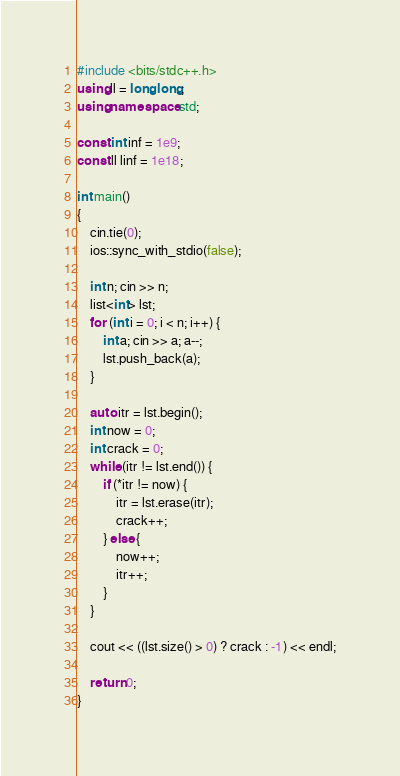<code> <loc_0><loc_0><loc_500><loc_500><_C++_>#include <bits/stdc++.h>
using ll = long long;
using namespace std;

const int inf = 1e9;
const ll linf = 1e18;

int main()
{
    cin.tie(0);
    ios::sync_with_stdio(false);

    int n; cin >> n;
    list<int> lst;
    for (int i = 0; i < n; i++) {
        int a; cin >> a; a--;
        lst.push_back(a);
    }

    auto itr = lst.begin();
    int now = 0;
    int crack = 0;
    while (itr != lst.end()) {
        if (*itr != now) {
            itr = lst.erase(itr);
            crack++;
        } else {
            now++;
            itr++;
        }
    }

    cout << ((lst.size() > 0) ? crack : -1) << endl;
    
    return 0;
}</code> 